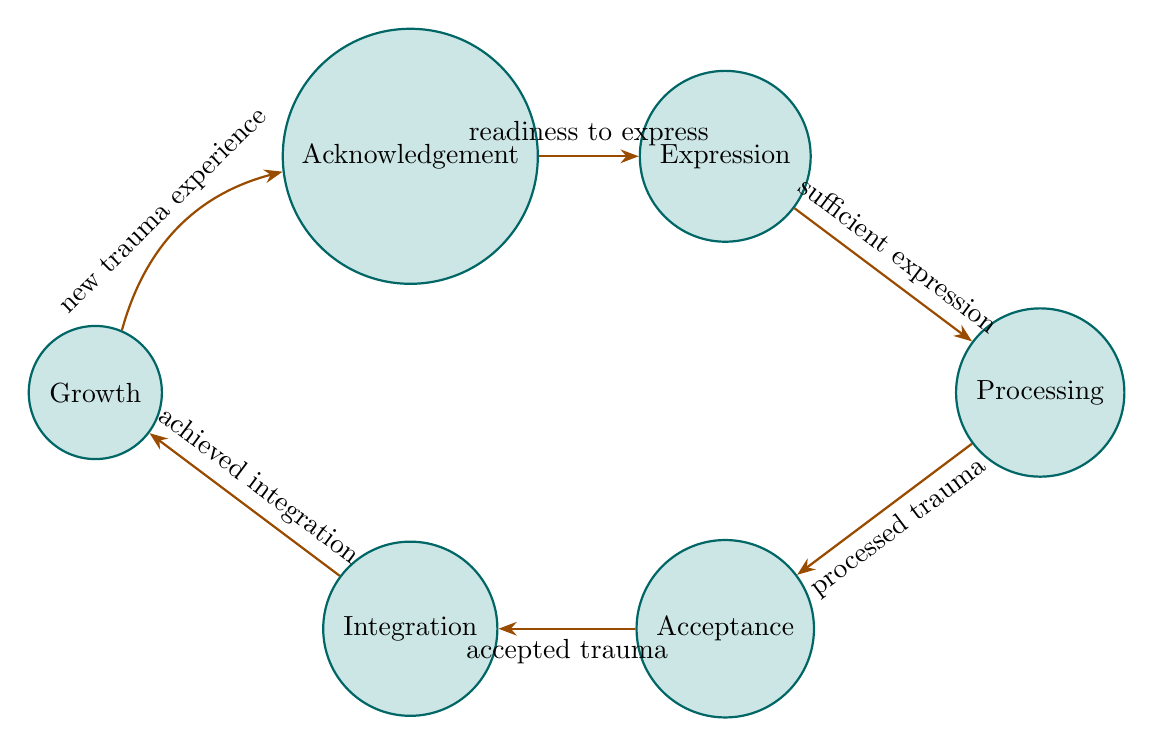What are the states represented in the diagram? The states in the diagram are Acknowledgement, Expression, Processing, Acceptance, Integration, and Growth. Each state represents a step in the emotional healing process.
Answer: Acknowledgement, Expression, Processing, Acceptance, Integration, Growth How many edges are there in the diagram? The diagram has five edges connecting the six states. Each edge represents a transition triggered by a specific condition.
Answer: 5 What condition transitions from Expression to Processing? The condition that transitions from Expression to Processing is "sufficient expression". This indicates the readiness of the person to progress to the next step after expressing their trauma.
Answer: sufficient expression What state comes after Acceptance? The state that comes after Acceptance is Integration. This step is about incorporating the trauma into one's identity in a healthy manner.
Answer: Integration What transition occurs when there is a new trauma experience? When there is a new trauma experience, the transition occurs from Growth back to Acknowledgement. This means that encountering new trauma might restart the emotional healing process.
Answer: Acknowledgement Which state focuses on recognizing personal growth? The state that focuses on recognizing personal growth is Growth. It emphasizes the resilience and positive changes that can arise from overcoming trauma.
Answer: Growth If someone has processed their trauma, what state do they transition to next? If someone has processed their trauma, they transition to the state of Acceptance, where they begin to come to terms with the trauma and its effects.
Answer: Acceptance What is the first condition that must be met to move from Acknowledgement to Expression? The first condition that must be met to move from Acknowledgement to Expression is "readiness to express". This signifies an individual's preparedness to share their feelings.
Answer: readiness to express What is the overall flow of the states in the emotional healing process? The overall flow of the states in the emotional healing process is Acknowledgement → Expression → Processing → Acceptance → Integration → Growth, and it can loop back to Acknowledgement with new trauma experiences.
Answer: Acknowledgement → Expression → Processing → Acceptance → Integration → Growth 